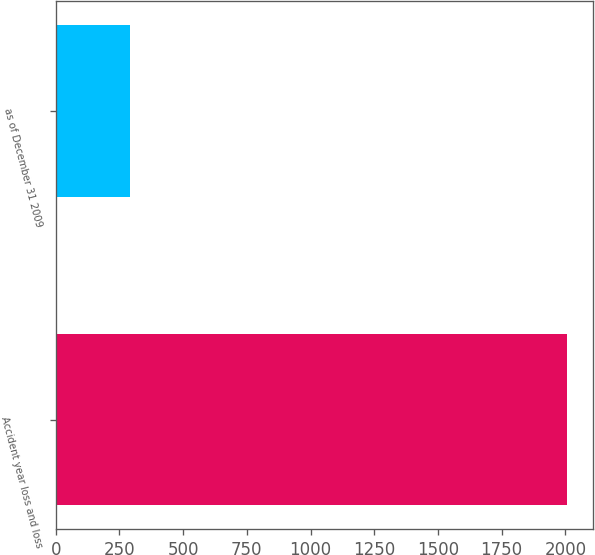<chart> <loc_0><loc_0><loc_500><loc_500><bar_chart><fcel>Accident year loss and loss<fcel>as of December 31 2009<nl><fcel>2008<fcel>292<nl></chart> 